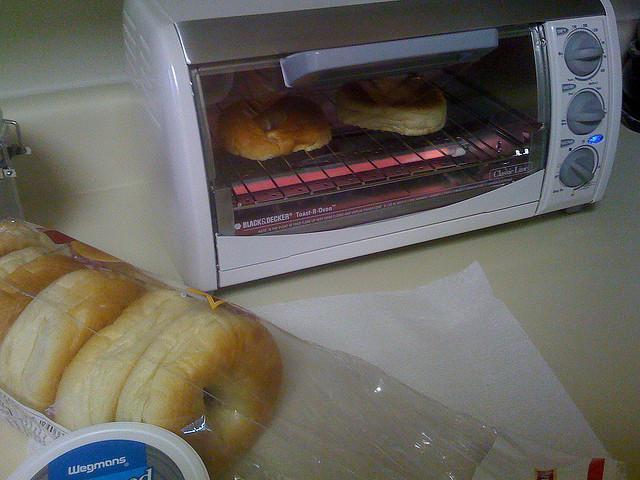How many bagels are being toasted?
Give a very brief answer. 1. How many ovens are in the photo?
Give a very brief answer. 1. How many donuts are there?
Give a very brief answer. 6. 